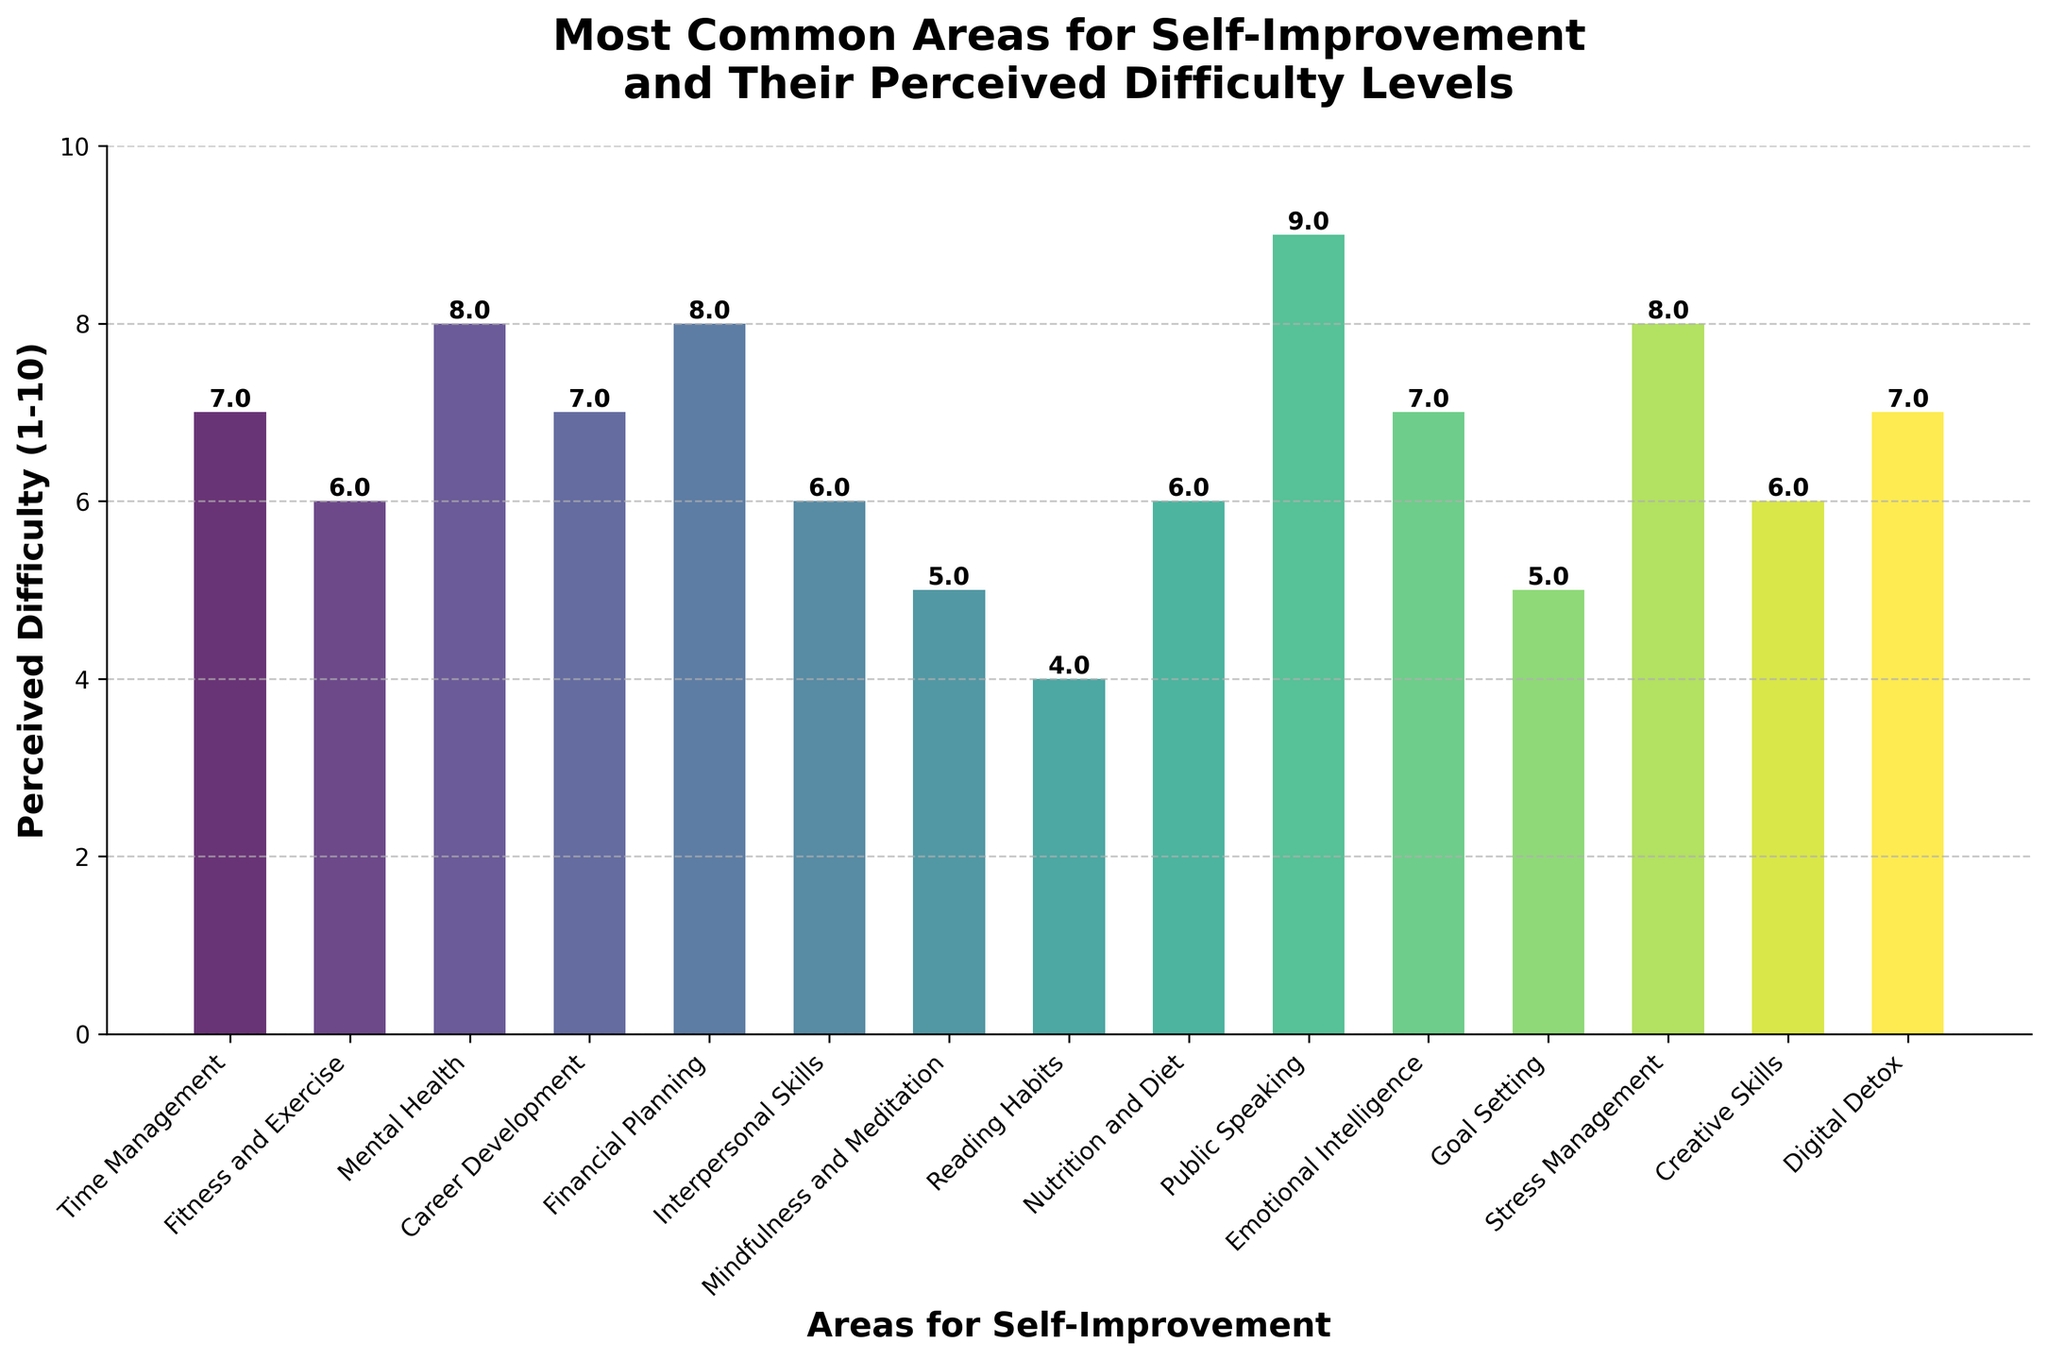Which area has the highest perceived difficulty level? The highest bar in the chart represents the area with the highest perceived difficulty level. By examining the chart, Public Speaking has the highest bar with a difficulty level of 9.
Answer: Public Speaking Which areas have a perceived difficulty level of 8? Look at the bars and their labels for the height corresponding to a difficulty level of 8. These areas are Mental Health, Financial Planning, and Stress Management.
Answer: Mental Health, Financial Planning, Stress Management What is the perceived difficulty difference between Fitness and Exercise and Public Speaking? Find the bars corresponding to Fitness and Exercise and Public Speaking. The perceived difficulty for Fitness and Exercise is 6, and for Public Speaking, it is 9. Subtract the former from the latter: 9 - 6.
Answer: 3 On average, how difficult are Interpersonal Skills, Nutrition and Diet, and Digital Detox perceived to be? These three areas have difficulty levels of 6, 6, and 7 respectively. Add these values and divide by 3: (6 + 6 + 7) / 3.
Answer: 6.33 Which area is perceived to be the least difficult? Find the shortest bar in the chart. Reading Habits has the lowest bar with a perceived difficulty level of 4.
Answer: Reading Habits How many areas have a perceived difficulty level greater than 7? Identify the bars that exceed the height level of 7. There are four such areas: Mental Health, Financial Planning, Public Speaking, and Stress Management.
Answer: 4 Is Nutrition and Diet perceived as more or less difficult than Career Development? Compare the height of the bars for Nutrition and Diet and Career Development. Both have the same difficulty level of 6.
Answer: Equal What is the combined perceived difficulty level of Time Management, Career Development, and Goal Setting? Look up the difficulty levels for these areas: Time Management (7), Career Development (7), and Goal Setting (5). Add these values together: 7 + 7 + 5.
Answer: 19 Which areas share the same perceived difficulty level as Fitness and Exercise? Fitness and Exercise has a perceived difficulty level of 6. The areas sharing this level are Interpersonal Skills, Nutrition and Diet, and Creative Skills.
Answer: Interpersonal Skills, Nutrition and Diet, Creative Skills Does Digital Detox have a higher or lower perceived difficulty level than Emotional Intelligence? Compare the height of the bars for Digital Detox and Emotional Intelligence. Both have the same difficulty level of 7.
Answer: Equal 